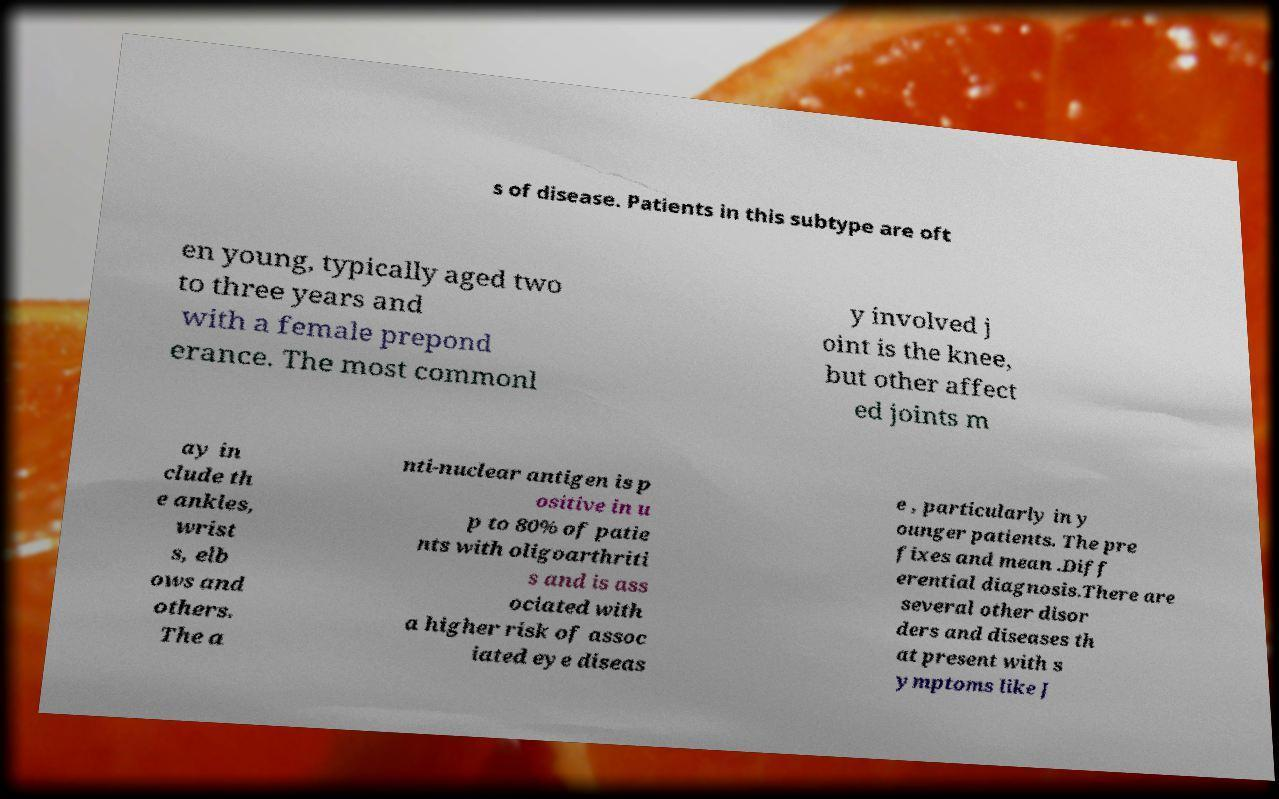Can you accurately transcribe the text from the provided image for me? s of disease. Patients in this subtype are oft en young, typically aged two to three years and with a female prepond erance. The most commonl y involved j oint is the knee, but other affect ed joints m ay in clude th e ankles, wrist s, elb ows and others. The a nti-nuclear antigen is p ositive in u p to 80% of patie nts with oligoarthriti s and is ass ociated with a higher risk of assoc iated eye diseas e , particularly in y ounger patients. The pre fixes and mean .Diff erential diagnosis.There are several other disor ders and diseases th at present with s ymptoms like J 